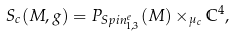Convert formula to latex. <formula><loc_0><loc_0><loc_500><loc_500>S _ { c } ( M , g ) = P _ { S p i n _ { 1 , 3 } ^ { e } } ( M ) \times _ { \mu _ { c } } \mathbb { C } ^ { 4 } ,</formula> 